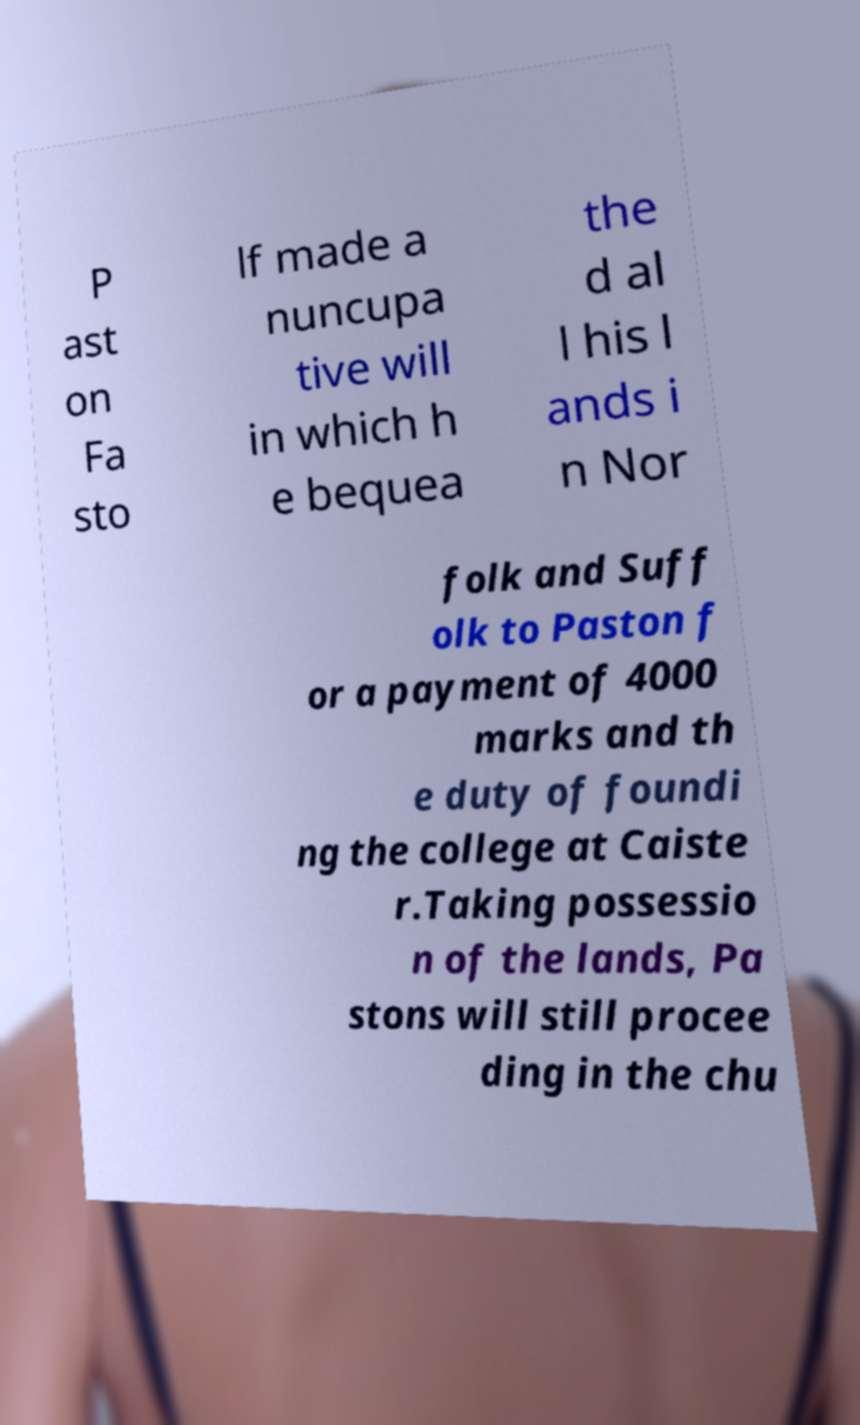Could you assist in decoding the text presented in this image and type it out clearly? P ast on Fa sto lf made a nuncupa tive will in which h e bequea the d al l his l ands i n Nor folk and Suff olk to Paston f or a payment of 4000 marks and th e duty of foundi ng the college at Caiste r.Taking possessio n of the lands, Pa stons will still procee ding in the chu 